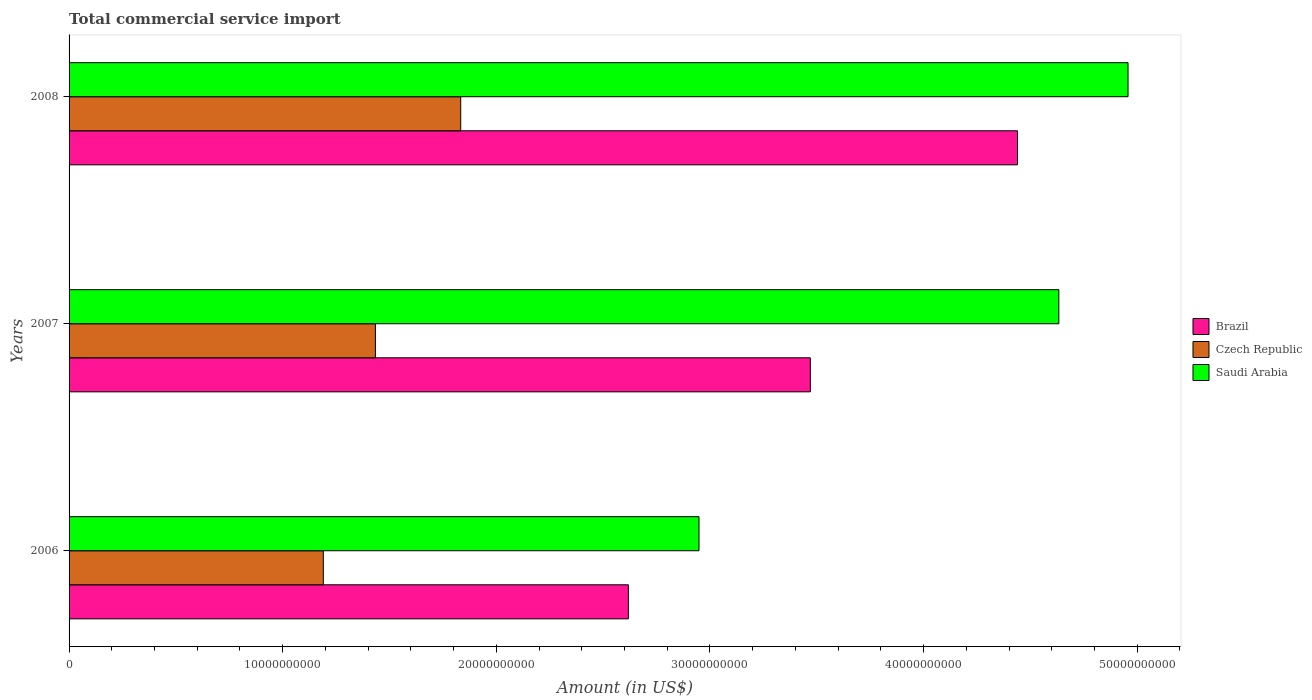How many different coloured bars are there?
Offer a terse response. 3. How many groups of bars are there?
Your answer should be compact. 3. Are the number of bars per tick equal to the number of legend labels?
Make the answer very short. Yes. How many bars are there on the 1st tick from the top?
Provide a short and direct response. 3. What is the label of the 3rd group of bars from the top?
Offer a terse response. 2006. What is the total commercial service import in Brazil in 2006?
Give a very brief answer. 2.62e+1. Across all years, what is the maximum total commercial service import in Czech Republic?
Provide a succinct answer. 1.83e+1. Across all years, what is the minimum total commercial service import in Saudi Arabia?
Your answer should be compact. 2.95e+1. In which year was the total commercial service import in Brazil minimum?
Ensure brevity in your answer.  2006. What is the total total commercial service import in Brazil in the graph?
Offer a terse response. 1.05e+11. What is the difference between the total commercial service import in Saudi Arabia in 2006 and that in 2007?
Your response must be concise. -1.68e+1. What is the difference between the total commercial service import in Brazil in 2006 and the total commercial service import in Czech Republic in 2008?
Give a very brief answer. 7.85e+09. What is the average total commercial service import in Czech Republic per year?
Provide a short and direct response. 1.49e+1. In the year 2008, what is the difference between the total commercial service import in Saudi Arabia and total commercial service import in Brazil?
Provide a succinct answer. 5.17e+09. In how many years, is the total commercial service import in Czech Republic greater than 32000000000 US$?
Your response must be concise. 0. What is the ratio of the total commercial service import in Czech Republic in 2006 to that in 2008?
Give a very brief answer. 0.65. Is the total commercial service import in Saudi Arabia in 2006 less than that in 2007?
Provide a short and direct response. Yes. What is the difference between the highest and the second highest total commercial service import in Saudi Arabia?
Provide a succinct answer. 3.24e+09. What is the difference between the highest and the lowest total commercial service import in Saudi Arabia?
Offer a very short reply. 2.01e+1. In how many years, is the total commercial service import in Saudi Arabia greater than the average total commercial service import in Saudi Arabia taken over all years?
Provide a short and direct response. 2. What does the 3rd bar from the bottom in 2008 represents?
Offer a very short reply. Saudi Arabia. What is the difference between two consecutive major ticks on the X-axis?
Ensure brevity in your answer.  1.00e+1. Does the graph contain any zero values?
Make the answer very short. No. Does the graph contain grids?
Provide a short and direct response. No. Where does the legend appear in the graph?
Your answer should be compact. Center right. What is the title of the graph?
Your answer should be compact. Total commercial service import. What is the label or title of the X-axis?
Offer a very short reply. Amount (in US$). What is the Amount (in US$) in Brazil in 2006?
Keep it short and to the point. 2.62e+1. What is the Amount (in US$) in Czech Republic in 2006?
Your answer should be compact. 1.19e+1. What is the Amount (in US$) in Saudi Arabia in 2006?
Your response must be concise. 2.95e+1. What is the Amount (in US$) in Brazil in 2007?
Offer a very short reply. 3.47e+1. What is the Amount (in US$) in Czech Republic in 2007?
Give a very brief answer. 1.43e+1. What is the Amount (in US$) of Saudi Arabia in 2007?
Keep it short and to the point. 4.63e+1. What is the Amount (in US$) in Brazil in 2008?
Make the answer very short. 4.44e+1. What is the Amount (in US$) in Czech Republic in 2008?
Keep it short and to the point. 1.83e+1. What is the Amount (in US$) in Saudi Arabia in 2008?
Your answer should be very brief. 4.96e+1. Across all years, what is the maximum Amount (in US$) of Brazil?
Keep it short and to the point. 4.44e+1. Across all years, what is the maximum Amount (in US$) in Czech Republic?
Offer a very short reply. 1.83e+1. Across all years, what is the maximum Amount (in US$) of Saudi Arabia?
Make the answer very short. 4.96e+1. Across all years, what is the minimum Amount (in US$) of Brazil?
Provide a short and direct response. 2.62e+1. Across all years, what is the minimum Amount (in US$) in Czech Republic?
Offer a terse response. 1.19e+1. Across all years, what is the minimum Amount (in US$) of Saudi Arabia?
Provide a short and direct response. 2.95e+1. What is the total Amount (in US$) in Brazil in the graph?
Your response must be concise. 1.05e+11. What is the total Amount (in US$) in Czech Republic in the graph?
Ensure brevity in your answer.  4.46e+1. What is the total Amount (in US$) in Saudi Arabia in the graph?
Your response must be concise. 1.25e+11. What is the difference between the Amount (in US$) in Brazil in 2006 and that in 2007?
Provide a short and direct response. -8.52e+09. What is the difference between the Amount (in US$) of Czech Republic in 2006 and that in 2007?
Your response must be concise. -2.44e+09. What is the difference between the Amount (in US$) in Saudi Arabia in 2006 and that in 2007?
Keep it short and to the point. -1.68e+1. What is the difference between the Amount (in US$) of Brazil in 2006 and that in 2008?
Keep it short and to the point. -1.82e+1. What is the difference between the Amount (in US$) in Czech Republic in 2006 and that in 2008?
Your answer should be very brief. -6.43e+09. What is the difference between the Amount (in US$) of Saudi Arabia in 2006 and that in 2008?
Your answer should be very brief. -2.01e+1. What is the difference between the Amount (in US$) in Brazil in 2007 and that in 2008?
Keep it short and to the point. -9.70e+09. What is the difference between the Amount (in US$) of Czech Republic in 2007 and that in 2008?
Your answer should be compact. -3.99e+09. What is the difference between the Amount (in US$) of Saudi Arabia in 2007 and that in 2008?
Your answer should be compact. -3.24e+09. What is the difference between the Amount (in US$) of Brazil in 2006 and the Amount (in US$) of Czech Republic in 2007?
Make the answer very short. 1.18e+1. What is the difference between the Amount (in US$) in Brazil in 2006 and the Amount (in US$) in Saudi Arabia in 2007?
Make the answer very short. -2.01e+1. What is the difference between the Amount (in US$) in Czech Republic in 2006 and the Amount (in US$) in Saudi Arabia in 2007?
Make the answer very short. -3.44e+1. What is the difference between the Amount (in US$) of Brazil in 2006 and the Amount (in US$) of Czech Republic in 2008?
Your answer should be very brief. 7.85e+09. What is the difference between the Amount (in US$) in Brazil in 2006 and the Amount (in US$) in Saudi Arabia in 2008?
Provide a succinct answer. -2.34e+1. What is the difference between the Amount (in US$) of Czech Republic in 2006 and the Amount (in US$) of Saudi Arabia in 2008?
Offer a terse response. -3.77e+1. What is the difference between the Amount (in US$) of Brazil in 2007 and the Amount (in US$) of Czech Republic in 2008?
Give a very brief answer. 1.64e+1. What is the difference between the Amount (in US$) of Brazil in 2007 and the Amount (in US$) of Saudi Arabia in 2008?
Provide a succinct answer. -1.49e+1. What is the difference between the Amount (in US$) in Czech Republic in 2007 and the Amount (in US$) in Saudi Arabia in 2008?
Make the answer very short. -3.52e+1. What is the average Amount (in US$) in Brazil per year?
Offer a very short reply. 3.51e+1. What is the average Amount (in US$) of Czech Republic per year?
Provide a succinct answer. 1.49e+1. What is the average Amount (in US$) of Saudi Arabia per year?
Give a very brief answer. 4.18e+1. In the year 2006, what is the difference between the Amount (in US$) of Brazil and Amount (in US$) of Czech Republic?
Your answer should be very brief. 1.43e+1. In the year 2006, what is the difference between the Amount (in US$) in Brazil and Amount (in US$) in Saudi Arabia?
Your response must be concise. -3.31e+09. In the year 2006, what is the difference between the Amount (in US$) of Czech Republic and Amount (in US$) of Saudi Arabia?
Your answer should be very brief. -1.76e+1. In the year 2007, what is the difference between the Amount (in US$) in Brazil and Amount (in US$) in Czech Republic?
Offer a very short reply. 2.04e+1. In the year 2007, what is the difference between the Amount (in US$) of Brazil and Amount (in US$) of Saudi Arabia?
Give a very brief answer. -1.16e+1. In the year 2007, what is the difference between the Amount (in US$) in Czech Republic and Amount (in US$) in Saudi Arabia?
Provide a short and direct response. -3.20e+1. In the year 2008, what is the difference between the Amount (in US$) in Brazil and Amount (in US$) in Czech Republic?
Give a very brief answer. 2.61e+1. In the year 2008, what is the difference between the Amount (in US$) in Brazil and Amount (in US$) in Saudi Arabia?
Your response must be concise. -5.17e+09. In the year 2008, what is the difference between the Amount (in US$) of Czech Republic and Amount (in US$) of Saudi Arabia?
Provide a succinct answer. -3.12e+1. What is the ratio of the Amount (in US$) in Brazil in 2006 to that in 2007?
Your answer should be very brief. 0.75. What is the ratio of the Amount (in US$) of Czech Republic in 2006 to that in 2007?
Your response must be concise. 0.83. What is the ratio of the Amount (in US$) of Saudi Arabia in 2006 to that in 2007?
Your response must be concise. 0.64. What is the ratio of the Amount (in US$) in Brazil in 2006 to that in 2008?
Keep it short and to the point. 0.59. What is the ratio of the Amount (in US$) of Czech Republic in 2006 to that in 2008?
Provide a succinct answer. 0.65. What is the ratio of the Amount (in US$) in Saudi Arabia in 2006 to that in 2008?
Give a very brief answer. 0.59. What is the ratio of the Amount (in US$) of Brazil in 2007 to that in 2008?
Your answer should be compact. 0.78. What is the ratio of the Amount (in US$) in Czech Republic in 2007 to that in 2008?
Your answer should be very brief. 0.78. What is the ratio of the Amount (in US$) in Saudi Arabia in 2007 to that in 2008?
Your response must be concise. 0.93. What is the difference between the highest and the second highest Amount (in US$) of Brazil?
Your response must be concise. 9.70e+09. What is the difference between the highest and the second highest Amount (in US$) of Czech Republic?
Your answer should be compact. 3.99e+09. What is the difference between the highest and the second highest Amount (in US$) in Saudi Arabia?
Keep it short and to the point. 3.24e+09. What is the difference between the highest and the lowest Amount (in US$) of Brazil?
Provide a short and direct response. 1.82e+1. What is the difference between the highest and the lowest Amount (in US$) in Czech Republic?
Your response must be concise. 6.43e+09. What is the difference between the highest and the lowest Amount (in US$) in Saudi Arabia?
Provide a succinct answer. 2.01e+1. 